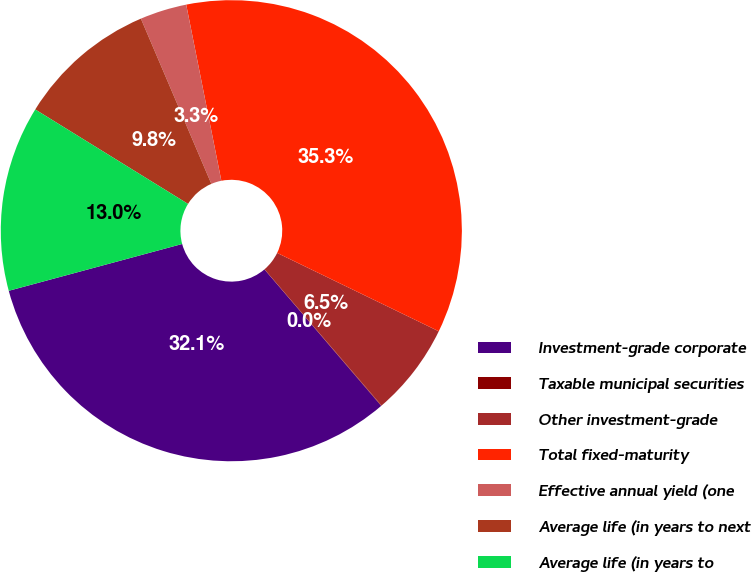Convert chart. <chart><loc_0><loc_0><loc_500><loc_500><pie_chart><fcel>Investment-grade corporate<fcel>Taxable municipal securities<fcel>Other investment-grade<fcel>Total fixed-maturity<fcel>Effective annual yield (one<fcel>Average life (in years to next<fcel>Average life (in years to<nl><fcel>32.07%<fcel>0.03%<fcel>6.52%<fcel>35.32%<fcel>3.28%<fcel>9.77%<fcel>13.01%<nl></chart> 